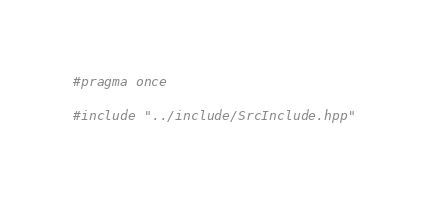<code> <loc_0><loc_0><loc_500><loc_500><_C++_>#pragma once

#include "../include/SrcInclude.hpp"</code> 